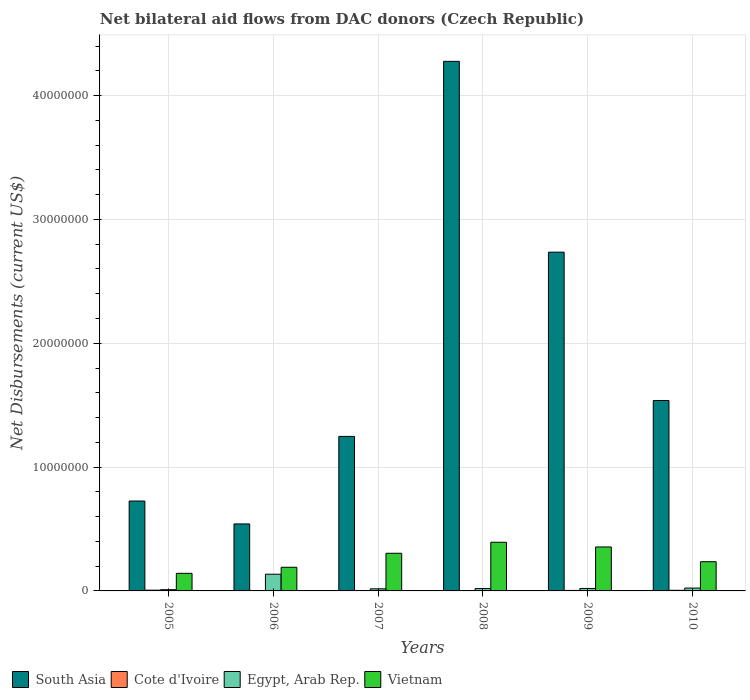How many different coloured bars are there?
Your response must be concise. 4. How many groups of bars are there?
Ensure brevity in your answer.  6. Are the number of bars per tick equal to the number of legend labels?
Keep it short and to the point. Yes. Are the number of bars on each tick of the X-axis equal?
Your response must be concise. Yes. How many bars are there on the 5th tick from the left?
Give a very brief answer. 4. How many bars are there on the 3rd tick from the right?
Your response must be concise. 4. What is the label of the 3rd group of bars from the left?
Keep it short and to the point. 2007. In how many cases, is the number of bars for a given year not equal to the number of legend labels?
Make the answer very short. 0. What is the net bilateral aid flows in Vietnam in 2008?
Make the answer very short. 3.93e+06. Across all years, what is the maximum net bilateral aid flows in Egypt, Arab Rep.?
Your answer should be very brief. 1.35e+06. Across all years, what is the minimum net bilateral aid flows in Cote d'Ivoire?
Keep it short and to the point. 10000. In which year was the net bilateral aid flows in Egypt, Arab Rep. maximum?
Keep it short and to the point. 2006. In which year was the net bilateral aid flows in Vietnam minimum?
Your response must be concise. 2005. What is the total net bilateral aid flows in Vietnam in the graph?
Provide a short and direct response. 1.62e+07. What is the difference between the net bilateral aid flows in Cote d'Ivoire in 2005 and that in 2007?
Provide a succinct answer. 5.00e+04. What is the difference between the net bilateral aid flows in Egypt, Arab Rep. in 2008 and the net bilateral aid flows in Vietnam in 2010?
Offer a very short reply. -2.17e+06. What is the average net bilateral aid flows in South Asia per year?
Ensure brevity in your answer.  1.84e+07. In the year 2010, what is the difference between the net bilateral aid flows in Vietnam and net bilateral aid flows in Cote d'Ivoire?
Make the answer very short. 2.31e+06. In how many years, is the net bilateral aid flows in South Asia greater than 24000000 US$?
Provide a short and direct response. 2. What is the ratio of the net bilateral aid flows in Egypt, Arab Rep. in 2008 to that in 2010?
Your response must be concise. 0.83. Is the difference between the net bilateral aid flows in Vietnam in 2007 and 2010 greater than the difference between the net bilateral aid flows in Cote d'Ivoire in 2007 and 2010?
Provide a succinct answer. Yes. What is the difference between the highest and the second highest net bilateral aid flows in South Asia?
Offer a terse response. 1.54e+07. What is the difference between the highest and the lowest net bilateral aid flows in Cote d'Ivoire?
Give a very brief answer. 5.00e+04. In how many years, is the net bilateral aid flows in Vietnam greater than the average net bilateral aid flows in Vietnam taken over all years?
Provide a succinct answer. 3. Is the sum of the net bilateral aid flows in Vietnam in 2007 and 2008 greater than the maximum net bilateral aid flows in South Asia across all years?
Offer a very short reply. No. Is it the case that in every year, the sum of the net bilateral aid flows in Cote d'Ivoire and net bilateral aid flows in South Asia is greater than the sum of net bilateral aid flows in Egypt, Arab Rep. and net bilateral aid flows in Vietnam?
Your response must be concise. Yes. What does the 1st bar from the right in 2005 represents?
Give a very brief answer. Vietnam. How many bars are there?
Give a very brief answer. 24. Are all the bars in the graph horizontal?
Provide a succinct answer. No. How many years are there in the graph?
Offer a very short reply. 6. Does the graph contain any zero values?
Your answer should be compact. No. Does the graph contain grids?
Your answer should be compact. Yes. Where does the legend appear in the graph?
Your response must be concise. Bottom left. How many legend labels are there?
Give a very brief answer. 4. How are the legend labels stacked?
Your response must be concise. Horizontal. What is the title of the graph?
Offer a very short reply. Net bilateral aid flows from DAC donors (Czech Republic). Does "Kosovo" appear as one of the legend labels in the graph?
Make the answer very short. No. What is the label or title of the X-axis?
Offer a terse response. Years. What is the label or title of the Y-axis?
Provide a succinct answer. Net Disbursements (current US$). What is the Net Disbursements (current US$) in South Asia in 2005?
Provide a short and direct response. 7.26e+06. What is the Net Disbursements (current US$) in Vietnam in 2005?
Keep it short and to the point. 1.42e+06. What is the Net Disbursements (current US$) in South Asia in 2006?
Give a very brief answer. 5.41e+06. What is the Net Disbursements (current US$) in Cote d'Ivoire in 2006?
Your response must be concise. 3.00e+04. What is the Net Disbursements (current US$) in Egypt, Arab Rep. in 2006?
Your response must be concise. 1.35e+06. What is the Net Disbursements (current US$) in Vietnam in 2006?
Give a very brief answer. 1.91e+06. What is the Net Disbursements (current US$) in South Asia in 2007?
Provide a succinct answer. 1.25e+07. What is the Net Disbursements (current US$) in Vietnam in 2007?
Your answer should be very brief. 3.04e+06. What is the Net Disbursements (current US$) of South Asia in 2008?
Ensure brevity in your answer.  4.28e+07. What is the Net Disbursements (current US$) of Vietnam in 2008?
Your response must be concise. 3.93e+06. What is the Net Disbursements (current US$) of South Asia in 2009?
Give a very brief answer. 2.74e+07. What is the Net Disbursements (current US$) in Cote d'Ivoire in 2009?
Give a very brief answer. 4.00e+04. What is the Net Disbursements (current US$) in Egypt, Arab Rep. in 2009?
Offer a very short reply. 2.00e+05. What is the Net Disbursements (current US$) of Vietnam in 2009?
Your answer should be compact. 3.55e+06. What is the Net Disbursements (current US$) in South Asia in 2010?
Give a very brief answer. 1.54e+07. What is the Net Disbursements (current US$) in Vietnam in 2010?
Keep it short and to the point. 2.36e+06. Across all years, what is the maximum Net Disbursements (current US$) of South Asia?
Give a very brief answer. 4.28e+07. Across all years, what is the maximum Net Disbursements (current US$) of Cote d'Ivoire?
Provide a succinct answer. 6.00e+04. Across all years, what is the maximum Net Disbursements (current US$) of Egypt, Arab Rep.?
Offer a very short reply. 1.35e+06. Across all years, what is the maximum Net Disbursements (current US$) of Vietnam?
Your answer should be compact. 3.93e+06. Across all years, what is the minimum Net Disbursements (current US$) of South Asia?
Provide a short and direct response. 5.41e+06. Across all years, what is the minimum Net Disbursements (current US$) in Egypt, Arab Rep.?
Make the answer very short. 1.00e+05. Across all years, what is the minimum Net Disbursements (current US$) in Vietnam?
Offer a very short reply. 1.42e+06. What is the total Net Disbursements (current US$) in South Asia in the graph?
Your response must be concise. 1.11e+08. What is the total Net Disbursements (current US$) in Egypt, Arab Rep. in the graph?
Provide a succinct answer. 2.24e+06. What is the total Net Disbursements (current US$) of Vietnam in the graph?
Make the answer very short. 1.62e+07. What is the difference between the Net Disbursements (current US$) in South Asia in 2005 and that in 2006?
Your answer should be compact. 1.85e+06. What is the difference between the Net Disbursements (current US$) of Cote d'Ivoire in 2005 and that in 2006?
Ensure brevity in your answer.  3.00e+04. What is the difference between the Net Disbursements (current US$) in Egypt, Arab Rep. in 2005 and that in 2006?
Provide a succinct answer. -1.25e+06. What is the difference between the Net Disbursements (current US$) of Vietnam in 2005 and that in 2006?
Give a very brief answer. -4.90e+05. What is the difference between the Net Disbursements (current US$) of South Asia in 2005 and that in 2007?
Your response must be concise. -5.22e+06. What is the difference between the Net Disbursements (current US$) in Cote d'Ivoire in 2005 and that in 2007?
Provide a succinct answer. 5.00e+04. What is the difference between the Net Disbursements (current US$) in Vietnam in 2005 and that in 2007?
Your response must be concise. -1.62e+06. What is the difference between the Net Disbursements (current US$) of South Asia in 2005 and that in 2008?
Your answer should be compact. -3.55e+07. What is the difference between the Net Disbursements (current US$) of Cote d'Ivoire in 2005 and that in 2008?
Offer a very short reply. 4.00e+04. What is the difference between the Net Disbursements (current US$) of Vietnam in 2005 and that in 2008?
Make the answer very short. -2.51e+06. What is the difference between the Net Disbursements (current US$) of South Asia in 2005 and that in 2009?
Your answer should be compact. -2.01e+07. What is the difference between the Net Disbursements (current US$) of Egypt, Arab Rep. in 2005 and that in 2009?
Keep it short and to the point. -1.00e+05. What is the difference between the Net Disbursements (current US$) of Vietnam in 2005 and that in 2009?
Provide a succinct answer. -2.13e+06. What is the difference between the Net Disbursements (current US$) in South Asia in 2005 and that in 2010?
Keep it short and to the point. -8.12e+06. What is the difference between the Net Disbursements (current US$) of Cote d'Ivoire in 2005 and that in 2010?
Provide a short and direct response. 10000. What is the difference between the Net Disbursements (current US$) of Vietnam in 2005 and that in 2010?
Your answer should be very brief. -9.40e+05. What is the difference between the Net Disbursements (current US$) of South Asia in 2006 and that in 2007?
Offer a very short reply. -7.07e+06. What is the difference between the Net Disbursements (current US$) of Cote d'Ivoire in 2006 and that in 2007?
Offer a terse response. 2.00e+04. What is the difference between the Net Disbursements (current US$) of Egypt, Arab Rep. in 2006 and that in 2007?
Ensure brevity in your answer.  1.18e+06. What is the difference between the Net Disbursements (current US$) of Vietnam in 2006 and that in 2007?
Provide a succinct answer. -1.13e+06. What is the difference between the Net Disbursements (current US$) in South Asia in 2006 and that in 2008?
Your response must be concise. -3.74e+07. What is the difference between the Net Disbursements (current US$) in Cote d'Ivoire in 2006 and that in 2008?
Keep it short and to the point. 10000. What is the difference between the Net Disbursements (current US$) in Egypt, Arab Rep. in 2006 and that in 2008?
Provide a succinct answer. 1.16e+06. What is the difference between the Net Disbursements (current US$) in Vietnam in 2006 and that in 2008?
Your answer should be very brief. -2.02e+06. What is the difference between the Net Disbursements (current US$) in South Asia in 2006 and that in 2009?
Your answer should be compact. -2.20e+07. What is the difference between the Net Disbursements (current US$) in Cote d'Ivoire in 2006 and that in 2009?
Your answer should be very brief. -10000. What is the difference between the Net Disbursements (current US$) in Egypt, Arab Rep. in 2006 and that in 2009?
Ensure brevity in your answer.  1.15e+06. What is the difference between the Net Disbursements (current US$) in Vietnam in 2006 and that in 2009?
Your answer should be very brief. -1.64e+06. What is the difference between the Net Disbursements (current US$) of South Asia in 2006 and that in 2010?
Your answer should be compact. -9.97e+06. What is the difference between the Net Disbursements (current US$) of Cote d'Ivoire in 2006 and that in 2010?
Keep it short and to the point. -2.00e+04. What is the difference between the Net Disbursements (current US$) in Egypt, Arab Rep. in 2006 and that in 2010?
Your answer should be very brief. 1.12e+06. What is the difference between the Net Disbursements (current US$) of Vietnam in 2006 and that in 2010?
Provide a short and direct response. -4.50e+05. What is the difference between the Net Disbursements (current US$) of South Asia in 2007 and that in 2008?
Your response must be concise. -3.03e+07. What is the difference between the Net Disbursements (current US$) in Vietnam in 2007 and that in 2008?
Keep it short and to the point. -8.90e+05. What is the difference between the Net Disbursements (current US$) in South Asia in 2007 and that in 2009?
Ensure brevity in your answer.  -1.49e+07. What is the difference between the Net Disbursements (current US$) of Vietnam in 2007 and that in 2009?
Make the answer very short. -5.10e+05. What is the difference between the Net Disbursements (current US$) of South Asia in 2007 and that in 2010?
Offer a very short reply. -2.90e+06. What is the difference between the Net Disbursements (current US$) in Vietnam in 2007 and that in 2010?
Your response must be concise. 6.80e+05. What is the difference between the Net Disbursements (current US$) of South Asia in 2008 and that in 2009?
Make the answer very short. 1.54e+07. What is the difference between the Net Disbursements (current US$) in Egypt, Arab Rep. in 2008 and that in 2009?
Provide a short and direct response. -10000. What is the difference between the Net Disbursements (current US$) in Vietnam in 2008 and that in 2009?
Your response must be concise. 3.80e+05. What is the difference between the Net Disbursements (current US$) in South Asia in 2008 and that in 2010?
Provide a succinct answer. 2.74e+07. What is the difference between the Net Disbursements (current US$) of Egypt, Arab Rep. in 2008 and that in 2010?
Give a very brief answer. -4.00e+04. What is the difference between the Net Disbursements (current US$) in Vietnam in 2008 and that in 2010?
Your answer should be compact. 1.57e+06. What is the difference between the Net Disbursements (current US$) in South Asia in 2009 and that in 2010?
Your answer should be compact. 1.20e+07. What is the difference between the Net Disbursements (current US$) of Vietnam in 2009 and that in 2010?
Provide a short and direct response. 1.19e+06. What is the difference between the Net Disbursements (current US$) in South Asia in 2005 and the Net Disbursements (current US$) in Cote d'Ivoire in 2006?
Your response must be concise. 7.23e+06. What is the difference between the Net Disbursements (current US$) in South Asia in 2005 and the Net Disbursements (current US$) in Egypt, Arab Rep. in 2006?
Give a very brief answer. 5.91e+06. What is the difference between the Net Disbursements (current US$) of South Asia in 2005 and the Net Disbursements (current US$) of Vietnam in 2006?
Provide a short and direct response. 5.35e+06. What is the difference between the Net Disbursements (current US$) in Cote d'Ivoire in 2005 and the Net Disbursements (current US$) in Egypt, Arab Rep. in 2006?
Give a very brief answer. -1.29e+06. What is the difference between the Net Disbursements (current US$) of Cote d'Ivoire in 2005 and the Net Disbursements (current US$) of Vietnam in 2006?
Keep it short and to the point. -1.85e+06. What is the difference between the Net Disbursements (current US$) of Egypt, Arab Rep. in 2005 and the Net Disbursements (current US$) of Vietnam in 2006?
Offer a terse response. -1.81e+06. What is the difference between the Net Disbursements (current US$) of South Asia in 2005 and the Net Disbursements (current US$) of Cote d'Ivoire in 2007?
Provide a short and direct response. 7.25e+06. What is the difference between the Net Disbursements (current US$) in South Asia in 2005 and the Net Disbursements (current US$) in Egypt, Arab Rep. in 2007?
Keep it short and to the point. 7.09e+06. What is the difference between the Net Disbursements (current US$) of South Asia in 2005 and the Net Disbursements (current US$) of Vietnam in 2007?
Keep it short and to the point. 4.22e+06. What is the difference between the Net Disbursements (current US$) of Cote d'Ivoire in 2005 and the Net Disbursements (current US$) of Vietnam in 2007?
Ensure brevity in your answer.  -2.98e+06. What is the difference between the Net Disbursements (current US$) in Egypt, Arab Rep. in 2005 and the Net Disbursements (current US$) in Vietnam in 2007?
Provide a succinct answer. -2.94e+06. What is the difference between the Net Disbursements (current US$) of South Asia in 2005 and the Net Disbursements (current US$) of Cote d'Ivoire in 2008?
Offer a very short reply. 7.24e+06. What is the difference between the Net Disbursements (current US$) of South Asia in 2005 and the Net Disbursements (current US$) of Egypt, Arab Rep. in 2008?
Your answer should be very brief. 7.07e+06. What is the difference between the Net Disbursements (current US$) of South Asia in 2005 and the Net Disbursements (current US$) of Vietnam in 2008?
Your answer should be very brief. 3.33e+06. What is the difference between the Net Disbursements (current US$) in Cote d'Ivoire in 2005 and the Net Disbursements (current US$) in Vietnam in 2008?
Offer a very short reply. -3.87e+06. What is the difference between the Net Disbursements (current US$) of Egypt, Arab Rep. in 2005 and the Net Disbursements (current US$) of Vietnam in 2008?
Give a very brief answer. -3.83e+06. What is the difference between the Net Disbursements (current US$) of South Asia in 2005 and the Net Disbursements (current US$) of Cote d'Ivoire in 2009?
Your response must be concise. 7.22e+06. What is the difference between the Net Disbursements (current US$) in South Asia in 2005 and the Net Disbursements (current US$) in Egypt, Arab Rep. in 2009?
Provide a succinct answer. 7.06e+06. What is the difference between the Net Disbursements (current US$) in South Asia in 2005 and the Net Disbursements (current US$) in Vietnam in 2009?
Provide a succinct answer. 3.71e+06. What is the difference between the Net Disbursements (current US$) of Cote d'Ivoire in 2005 and the Net Disbursements (current US$) of Vietnam in 2009?
Make the answer very short. -3.49e+06. What is the difference between the Net Disbursements (current US$) in Egypt, Arab Rep. in 2005 and the Net Disbursements (current US$) in Vietnam in 2009?
Offer a terse response. -3.45e+06. What is the difference between the Net Disbursements (current US$) of South Asia in 2005 and the Net Disbursements (current US$) of Cote d'Ivoire in 2010?
Offer a terse response. 7.21e+06. What is the difference between the Net Disbursements (current US$) of South Asia in 2005 and the Net Disbursements (current US$) of Egypt, Arab Rep. in 2010?
Offer a very short reply. 7.03e+06. What is the difference between the Net Disbursements (current US$) in South Asia in 2005 and the Net Disbursements (current US$) in Vietnam in 2010?
Ensure brevity in your answer.  4.90e+06. What is the difference between the Net Disbursements (current US$) of Cote d'Ivoire in 2005 and the Net Disbursements (current US$) of Vietnam in 2010?
Your answer should be compact. -2.30e+06. What is the difference between the Net Disbursements (current US$) in Egypt, Arab Rep. in 2005 and the Net Disbursements (current US$) in Vietnam in 2010?
Offer a terse response. -2.26e+06. What is the difference between the Net Disbursements (current US$) of South Asia in 2006 and the Net Disbursements (current US$) of Cote d'Ivoire in 2007?
Make the answer very short. 5.40e+06. What is the difference between the Net Disbursements (current US$) in South Asia in 2006 and the Net Disbursements (current US$) in Egypt, Arab Rep. in 2007?
Your response must be concise. 5.24e+06. What is the difference between the Net Disbursements (current US$) in South Asia in 2006 and the Net Disbursements (current US$) in Vietnam in 2007?
Offer a terse response. 2.37e+06. What is the difference between the Net Disbursements (current US$) of Cote d'Ivoire in 2006 and the Net Disbursements (current US$) of Egypt, Arab Rep. in 2007?
Make the answer very short. -1.40e+05. What is the difference between the Net Disbursements (current US$) of Cote d'Ivoire in 2006 and the Net Disbursements (current US$) of Vietnam in 2007?
Provide a short and direct response. -3.01e+06. What is the difference between the Net Disbursements (current US$) in Egypt, Arab Rep. in 2006 and the Net Disbursements (current US$) in Vietnam in 2007?
Your response must be concise. -1.69e+06. What is the difference between the Net Disbursements (current US$) in South Asia in 2006 and the Net Disbursements (current US$) in Cote d'Ivoire in 2008?
Offer a very short reply. 5.39e+06. What is the difference between the Net Disbursements (current US$) in South Asia in 2006 and the Net Disbursements (current US$) in Egypt, Arab Rep. in 2008?
Give a very brief answer. 5.22e+06. What is the difference between the Net Disbursements (current US$) in South Asia in 2006 and the Net Disbursements (current US$) in Vietnam in 2008?
Your answer should be compact. 1.48e+06. What is the difference between the Net Disbursements (current US$) in Cote d'Ivoire in 2006 and the Net Disbursements (current US$) in Egypt, Arab Rep. in 2008?
Your response must be concise. -1.60e+05. What is the difference between the Net Disbursements (current US$) of Cote d'Ivoire in 2006 and the Net Disbursements (current US$) of Vietnam in 2008?
Give a very brief answer. -3.90e+06. What is the difference between the Net Disbursements (current US$) of Egypt, Arab Rep. in 2006 and the Net Disbursements (current US$) of Vietnam in 2008?
Make the answer very short. -2.58e+06. What is the difference between the Net Disbursements (current US$) of South Asia in 2006 and the Net Disbursements (current US$) of Cote d'Ivoire in 2009?
Provide a succinct answer. 5.37e+06. What is the difference between the Net Disbursements (current US$) of South Asia in 2006 and the Net Disbursements (current US$) of Egypt, Arab Rep. in 2009?
Your answer should be compact. 5.21e+06. What is the difference between the Net Disbursements (current US$) in South Asia in 2006 and the Net Disbursements (current US$) in Vietnam in 2009?
Your response must be concise. 1.86e+06. What is the difference between the Net Disbursements (current US$) in Cote d'Ivoire in 2006 and the Net Disbursements (current US$) in Egypt, Arab Rep. in 2009?
Give a very brief answer. -1.70e+05. What is the difference between the Net Disbursements (current US$) in Cote d'Ivoire in 2006 and the Net Disbursements (current US$) in Vietnam in 2009?
Your answer should be very brief. -3.52e+06. What is the difference between the Net Disbursements (current US$) of Egypt, Arab Rep. in 2006 and the Net Disbursements (current US$) of Vietnam in 2009?
Provide a succinct answer. -2.20e+06. What is the difference between the Net Disbursements (current US$) of South Asia in 2006 and the Net Disbursements (current US$) of Cote d'Ivoire in 2010?
Your answer should be very brief. 5.36e+06. What is the difference between the Net Disbursements (current US$) in South Asia in 2006 and the Net Disbursements (current US$) in Egypt, Arab Rep. in 2010?
Ensure brevity in your answer.  5.18e+06. What is the difference between the Net Disbursements (current US$) of South Asia in 2006 and the Net Disbursements (current US$) of Vietnam in 2010?
Give a very brief answer. 3.05e+06. What is the difference between the Net Disbursements (current US$) of Cote d'Ivoire in 2006 and the Net Disbursements (current US$) of Vietnam in 2010?
Provide a short and direct response. -2.33e+06. What is the difference between the Net Disbursements (current US$) of Egypt, Arab Rep. in 2006 and the Net Disbursements (current US$) of Vietnam in 2010?
Give a very brief answer. -1.01e+06. What is the difference between the Net Disbursements (current US$) in South Asia in 2007 and the Net Disbursements (current US$) in Cote d'Ivoire in 2008?
Make the answer very short. 1.25e+07. What is the difference between the Net Disbursements (current US$) of South Asia in 2007 and the Net Disbursements (current US$) of Egypt, Arab Rep. in 2008?
Give a very brief answer. 1.23e+07. What is the difference between the Net Disbursements (current US$) in South Asia in 2007 and the Net Disbursements (current US$) in Vietnam in 2008?
Your answer should be compact. 8.55e+06. What is the difference between the Net Disbursements (current US$) in Cote d'Ivoire in 2007 and the Net Disbursements (current US$) in Vietnam in 2008?
Your answer should be very brief. -3.92e+06. What is the difference between the Net Disbursements (current US$) of Egypt, Arab Rep. in 2007 and the Net Disbursements (current US$) of Vietnam in 2008?
Keep it short and to the point. -3.76e+06. What is the difference between the Net Disbursements (current US$) of South Asia in 2007 and the Net Disbursements (current US$) of Cote d'Ivoire in 2009?
Offer a very short reply. 1.24e+07. What is the difference between the Net Disbursements (current US$) of South Asia in 2007 and the Net Disbursements (current US$) of Egypt, Arab Rep. in 2009?
Your response must be concise. 1.23e+07. What is the difference between the Net Disbursements (current US$) in South Asia in 2007 and the Net Disbursements (current US$) in Vietnam in 2009?
Give a very brief answer. 8.93e+06. What is the difference between the Net Disbursements (current US$) of Cote d'Ivoire in 2007 and the Net Disbursements (current US$) of Egypt, Arab Rep. in 2009?
Offer a terse response. -1.90e+05. What is the difference between the Net Disbursements (current US$) in Cote d'Ivoire in 2007 and the Net Disbursements (current US$) in Vietnam in 2009?
Offer a terse response. -3.54e+06. What is the difference between the Net Disbursements (current US$) of Egypt, Arab Rep. in 2007 and the Net Disbursements (current US$) of Vietnam in 2009?
Offer a terse response. -3.38e+06. What is the difference between the Net Disbursements (current US$) in South Asia in 2007 and the Net Disbursements (current US$) in Cote d'Ivoire in 2010?
Your answer should be very brief. 1.24e+07. What is the difference between the Net Disbursements (current US$) of South Asia in 2007 and the Net Disbursements (current US$) of Egypt, Arab Rep. in 2010?
Ensure brevity in your answer.  1.22e+07. What is the difference between the Net Disbursements (current US$) in South Asia in 2007 and the Net Disbursements (current US$) in Vietnam in 2010?
Give a very brief answer. 1.01e+07. What is the difference between the Net Disbursements (current US$) of Cote d'Ivoire in 2007 and the Net Disbursements (current US$) of Egypt, Arab Rep. in 2010?
Your response must be concise. -2.20e+05. What is the difference between the Net Disbursements (current US$) in Cote d'Ivoire in 2007 and the Net Disbursements (current US$) in Vietnam in 2010?
Your answer should be very brief. -2.35e+06. What is the difference between the Net Disbursements (current US$) of Egypt, Arab Rep. in 2007 and the Net Disbursements (current US$) of Vietnam in 2010?
Make the answer very short. -2.19e+06. What is the difference between the Net Disbursements (current US$) in South Asia in 2008 and the Net Disbursements (current US$) in Cote d'Ivoire in 2009?
Ensure brevity in your answer.  4.27e+07. What is the difference between the Net Disbursements (current US$) in South Asia in 2008 and the Net Disbursements (current US$) in Egypt, Arab Rep. in 2009?
Keep it short and to the point. 4.26e+07. What is the difference between the Net Disbursements (current US$) of South Asia in 2008 and the Net Disbursements (current US$) of Vietnam in 2009?
Keep it short and to the point. 3.92e+07. What is the difference between the Net Disbursements (current US$) of Cote d'Ivoire in 2008 and the Net Disbursements (current US$) of Vietnam in 2009?
Your answer should be compact. -3.53e+06. What is the difference between the Net Disbursements (current US$) in Egypt, Arab Rep. in 2008 and the Net Disbursements (current US$) in Vietnam in 2009?
Make the answer very short. -3.36e+06. What is the difference between the Net Disbursements (current US$) in South Asia in 2008 and the Net Disbursements (current US$) in Cote d'Ivoire in 2010?
Your response must be concise. 4.27e+07. What is the difference between the Net Disbursements (current US$) of South Asia in 2008 and the Net Disbursements (current US$) of Egypt, Arab Rep. in 2010?
Give a very brief answer. 4.25e+07. What is the difference between the Net Disbursements (current US$) of South Asia in 2008 and the Net Disbursements (current US$) of Vietnam in 2010?
Your answer should be compact. 4.04e+07. What is the difference between the Net Disbursements (current US$) in Cote d'Ivoire in 2008 and the Net Disbursements (current US$) in Vietnam in 2010?
Your answer should be very brief. -2.34e+06. What is the difference between the Net Disbursements (current US$) of Egypt, Arab Rep. in 2008 and the Net Disbursements (current US$) of Vietnam in 2010?
Your response must be concise. -2.17e+06. What is the difference between the Net Disbursements (current US$) of South Asia in 2009 and the Net Disbursements (current US$) of Cote d'Ivoire in 2010?
Your response must be concise. 2.73e+07. What is the difference between the Net Disbursements (current US$) in South Asia in 2009 and the Net Disbursements (current US$) in Egypt, Arab Rep. in 2010?
Provide a short and direct response. 2.71e+07. What is the difference between the Net Disbursements (current US$) in South Asia in 2009 and the Net Disbursements (current US$) in Vietnam in 2010?
Keep it short and to the point. 2.50e+07. What is the difference between the Net Disbursements (current US$) in Cote d'Ivoire in 2009 and the Net Disbursements (current US$) in Egypt, Arab Rep. in 2010?
Your response must be concise. -1.90e+05. What is the difference between the Net Disbursements (current US$) in Cote d'Ivoire in 2009 and the Net Disbursements (current US$) in Vietnam in 2010?
Offer a terse response. -2.32e+06. What is the difference between the Net Disbursements (current US$) of Egypt, Arab Rep. in 2009 and the Net Disbursements (current US$) of Vietnam in 2010?
Make the answer very short. -2.16e+06. What is the average Net Disbursements (current US$) of South Asia per year?
Your response must be concise. 1.84e+07. What is the average Net Disbursements (current US$) in Cote d'Ivoire per year?
Ensure brevity in your answer.  3.50e+04. What is the average Net Disbursements (current US$) of Egypt, Arab Rep. per year?
Your response must be concise. 3.73e+05. What is the average Net Disbursements (current US$) in Vietnam per year?
Ensure brevity in your answer.  2.70e+06. In the year 2005, what is the difference between the Net Disbursements (current US$) in South Asia and Net Disbursements (current US$) in Cote d'Ivoire?
Offer a very short reply. 7.20e+06. In the year 2005, what is the difference between the Net Disbursements (current US$) in South Asia and Net Disbursements (current US$) in Egypt, Arab Rep.?
Your answer should be compact. 7.16e+06. In the year 2005, what is the difference between the Net Disbursements (current US$) of South Asia and Net Disbursements (current US$) of Vietnam?
Ensure brevity in your answer.  5.84e+06. In the year 2005, what is the difference between the Net Disbursements (current US$) in Cote d'Ivoire and Net Disbursements (current US$) in Egypt, Arab Rep.?
Offer a very short reply. -4.00e+04. In the year 2005, what is the difference between the Net Disbursements (current US$) in Cote d'Ivoire and Net Disbursements (current US$) in Vietnam?
Ensure brevity in your answer.  -1.36e+06. In the year 2005, what is the difference between the Net Disbursements (current US$) of Egypt, Arab Rep. and Net Disbursements (current US$) of Vietnam?
Ensure brevity in your answer.  -1.32e+06. In the year 2006, what is the difference between the Net Disbursements (current US$) in South Asia and Net Disbursements (current US$) in Cote d'Ivoire?
Keep it short and to the point. 5.38e+06. In the year 2006, what is the difference between the Net Disbursements (current US$) in South Asia and Net Disbursements (current US$) in Egypt, Arab Rep.?
Your answer should be compact. 4.06e+06. In the year 2006, what is the difference between the Net Disbursements (current US$) of South Asia and Net Disbursements (current US$) of Vietnam?
Give a very brief answer. 3.50e+06. In the year 2006, what is the difference between the Net Disbursements (current US$) of Cote d'Ivoire and Net Disbursements (current US$) of Egypt, Arab Rep.?
Make the answer very short. -1.32e+06. In the year 2006, what is the difference between the Net Disbursements (current US$) of Cote d'Ivoire and Net Disbursements (current US$) of Vietnam?
Your response must be concise. -1.88e+06. In the year 2006, what is the difference between the Net Disbursements (current US$) in Egypt, Arab Rep. and Net Disbursements (current US$) in Vietnam?
Keep it short and to the point. -5.60e+05. In the year 2007, what is the difference between the Net Disbursements (current US$) of South Asia and Net Disbursements (current US$) of Cote d'Ivoire?
Keep it short and to the point. 1.25e+07. In the year 2007, what is the difference between the Net Disbursements (current US$) in South Asia and Net Disbursements (current US$) in Egypt, Arab Rep.?
Provide a succinct answer. 1.23e+07. In the year 2007, what is the difference between the Net Disbursements (current US$) of South Asia and Net Disbursements (current US$) of Vietnam?
Offer a very short reply. 9.44e+06. In the year 2007, what is the difference between the Net Disbursements (current US$) of Cote d'Ivoire and Net Disbursements (current US$) of Vietnam?
Your answer should be very brief. -3.03e+06. In the year 2007, what is the difference between the Net Disbursements (current US$) in Egypt, Arab Rep. and Net Disbursements (current US$) in Vietnam?
Provide a succinct answer. -2.87e+06. In the year 2008, what is the difference between the Net Disbursements (current US$) in South Asia and Net Disbursements (current US$) in Cote d'Ivoire?
Make the answer very short. 4.28e+07. In the year 2008, what is the difference between the Net Disbursements (current US$) in South Asia and Net Disbursements (current US$) in Egypt, Arab Rep.?
Keep it short and to the point. 4.26e+07. In the year 2008, what is the difference between the Net Disbursements (current US$) in South Asia and Net Disbursements (current US$) in Vietnam?
Ensure brevity in your answer.  3.88e+07. In the year 2008, what is the difference between the Net Disbursements (current US$) of Cote d'Ivoire and Net Disbursements (current US$) of Vietnam?
Your response must be concise. -3.91e+06. In the year 2008, what is the difference between the Net Disbursements (current US$) of Egypt, Arab Rep. and Net Disbursements (current US$) of Vietnam?
Your response must be concise. -3.74e+06. In the year 2009, what is the difference between the Net Disbursements (current US$) in South Asia and Net Disbursements (current US$) in Cote d'Ivoire?
Provide a short and direct response. 2.73e+07. In the year 2009, what is the difference between the Net Disbursements (current US$) in South Asia and Net Disbursements (current US$) in Egypt, Arab Rep.?
Ensure brevity in your answer.  2.72e+07. In the year 2009, what is the difference between the Net Disbursements (current US$) in South Asia and Net Disbursements (current US$) in Vietnam?
Ensure brevity in your answer.  2.38e+07. In the year 2009, what is the difference between the Net Disbursements (current US$) of Cote d'Ivoire and Net Disbursements (current US$) of Egypt, Arab Rep.?
Offer a terse response. -1.60e+05. In the year 2009, what is the difference between the Net Disbursements (current US$) of Cote d'Ivoire and Net Disbursements (current US$) of Vietnam?
Offer a very short reply. -3.51e+06. In the year 2009, what is the difference between the Net Disbursements (current US$) in Egypt, Arab Rep. and Net Disbursements (current US$) in Vietnam?
Give a very brief answer. -3.35e+06. In the year 2010, what is the difference between the Net Disbursements (current US$) in South Asia and Net Disbursements (current US$) in Cote d'Ivoire?
Provide a short and direct response. 1.53e+07. In the year 2010, what is the difference between the Net Disbursements (current US$) in South Asia and Net Disbursements (current US$) in Egypt, Arab Rep.?
Your answer should be compact. 1.52e+07. In the year 2010, what is the difference between the Net Disbursements (current US$) of South Asia and Net Disbursements (current US$) of Vietnam?
Offer a very short reply. 1.30e+07. In the year 2010, what is the difference between the Net Disbursements (current US$) in Cote d'Ivoire and Net Disbursements (current US$) in Egypt, Arab Rep.?
Ensure brevity in your answer.  -1.80e+05. In the year 2010, what is the difference between the Net Disbursements (current US$) in Cote d'Ivoire and Net Disbursements (current US$) in Vietnam?
Your answer should be compact. -2.31e+06. In the year 2010, what is the difference between the Net Disbursements (current US$) of Egypt, Arab Rep. and Net Disbursements (current US$) of Vietnam?
Offer a very short reply. -2.13e+06. What is the ratio of the Net Disbursements (current US$) of South Asia in 2005 to that in 2006?
Your answer should be very brief. 1.34. What is the ratio of the Net Disbursements (current US$) in Egypt, Arab Rep. in 2005 to that in 2006?
Offer a terse response. 0.07. What is the ratio of the Net Disbursements (current US$) of Vietnam in 2005 to that in 2006?
Offer a very short reply. 0.74. What is the ratio of the Net Disbursements (current US$) of South Asia in 2005 to that in 2007?
Your answer should be very brief. 0.58. What is the ratio of the Net Disbursements (current US$) in Cote d'Ivoire in 2005 to that in 2007?
Ensure brevity in your answer.  6. What is the ratio of the Net Disbursements (current US$) of Egypt, Arab Rep. in 2005 to that in 2007?
Make the answer very short. 0.59. What is the ratio of the Net Disbursements (current US$) of Vietnam in 2005 to that in 2007?
Provide a succinct answer. 0.47. What is the ratio of the Net Disbursements (current US$) of South Asia in 2005 to that in 2008?
Keep it short and to the point. 0.17. What is the ratio of the Net Disbursements (current US$) of Cote d'Ivoire in 2005 to that in 2008?
Give a very brief answer. 3. What is the ratio of the Net Disbursements (current US$) of Egypt, Arab Rep. in 2005 to that in 2008?
Give a very brief answer. 0.53. What is the ratio of the Net Disbursements (current US$) of Vietnam in 2005 to that in 2008?
Make the answer very short. 0.36. What is the ratio of the Net Disbursements (current US$) in South Asia in 2005 to that in 2009?
Provide a succinct answer. 0.27. What is the ratio of the Net Disbursements (current US$) of Egypt, Arab Rep. in 2005 to that in 2009?
Your answer should be compact. 0.5. What is the ratio of the Net Disbursements (current US$) in Vietnam in 2005 to that in 2009?
Keep it short and to the point. 0.4. What is the ratio of the Net Disbursements (current US$) in South Asia in 2005 to that in 2010?
Offer a terse response. 0.47. What is the ratio of the Net Disbursements (current US$) in Cote d'Ivoire in 2005 to that in 2010?
Provide a short and direct response. 1.2. What is the ratio of the Net Disbursements (current US$) in Egypt, Arab Rep. in 2005 to that in 2010?
Your response must be concise. 0.43. What is the ratio of the Net Disbursements (current US$) of Vietnam in 2005 to that in 2010?
Make the answer very short. 0.6. What is the ratio of the Net Disbursements (current US$) in South Asia in 2006 to that in 2007?
Provide a succinct answer. 0.43. What is the ratio of the Net Disbursements (current US$) in Cote d'Ivoire in 2006 to that in 2007?
Provide a short and direct response. 3. What is the ratio of the Net Disbursements (current US$) in Egypt, Arab Rep. in 2006 to that in 2007?
Ensure brevity in your answer.  7.94. What is the ratio of the Net Disbursements (current US$) in Vietnam in 2006 to that in 2007?
Your answer should be very brief. 0.63. What is the ratio of the Net Disbursements (current US$) of South Asia in 2006 to that in 2008?
Offer a terse response. 0.13. What is the ratio of the Net Disbursements (current US$) of Cote d'Ivoire in 2006 to that in 2008?
Provide a succinct answer. 1.5. What is the ratio of the Net Disbursements (current US$) of Egypt, Arab Rep. in 2006 to that in 2008?
Offer a terse response. 7.11. What is the ratio of the Net Disbursements (current US$) of Vietnam in 2006 to that in 2008?
Provide a succinct answer. 0.49. What is the ratio of the Net Disbursements (current US$) of South Asia in 2006 to that in 2009?
Make the answer very short. 0.2. What is the ratio of the Net Disbursements (current US$) in Cote d'Ivoire in 2006 to that in 2009?
Your answer should be very brief. 0.75. What is the ratio of the Net Disbursements (current US$) in Egypt, Arab Rep. in 2006 to that in 2009?
Provide a succinct answer. 6.75. What is the ratio of the Net Disbursements (current US$) in Vietnam in 2006 to that in 2009?
Your response must be concise. 0.54. What is the ratio of the Net Disbursements (current US$) in South Asia in 2006 to that in 2010?
Your answer should be very brief. 0.35. What is the ratio of the Net Disbursements (current US$) of Egypt, Arab Rep. in 2006 to that in 2010?
Your answer should be very brief. 5.87. What is the ratio of the Net Disbursements (current US$) in Vietnam in 2006 to that in 2010?
Provide a short and direct response. 0.81. What is the ratio of the Net Disbursements (current US$) of South Asia in 2007 to that in 2008?
Offer a very short reply. 0.29. What is the ratio of the Net Disbursements (current US$) of Egypt, Arab Rep. in 2007 to that in 2008?
Ensure brevity in your answer.  0.89. What is the ratio of the Net Disbursements (current US$) in Vietnam in 2007 to that in 2008?
Keep it short and to the point. 0.77. What is the ratio of the Net Disbursements (current US$) of South Asia in 2007 to that in 2009?
Provide a succinct answer. 0.46. What is the ratio of the Net Disbursements (current US$) in Cote d'Ivoire in 2007 to that in 2009?
Provide a short and direct response. 0.25. What is the ratio of the Net Disbursements (current US$) of Vietnam in 2007 to that in 2009?
Provide a succinct answer. 0.86. What is the ratio of the Net Disbursements (current US$) of South Asia in 2007 to that in 2010?
Provide a short and direct response. 0.81. What is the ratio of the Net Disbursements (current US$) in Egypt, Arab Rep. in 2007 to that in 2010?
Your answer should be compact. 0.74. What is the ratio of the Net Disbursements (current US$) of Vietnam in 2007 to that in 2010?
Keep it short and to the point. 1.29. What is the ratio of the Net Disbursements (current US$) in South Asia in 2008 to that in 2009?
Your response must be concise. 1.56. What is the ratio of the Net Disbursements (current US$) of Egypt, Arab Rep. in 2008 to that in 2009?
Provide a short and direct response. 0.95. What is the ratio of the Net Disbursements (current US$) in Vietnam in 2008 to that in 2009?
Ensure brevity in your answer.  1.11. What is the ratio of the Net Disbursements (current US$) in South Asia in 2008 to that in 2010?
Keep it short and to the point. 2.78. What is the ratio of the Net Disbursements (current US$) in Egypt, Arab Rep. in 2008 to that in 2010?
Make the answer very short. 0.83. What is the ratio of the Net Disbursements (current US$) in Vietnam in 2008 to that in 2010?
Give a very brief answer. 1.67. What is the ratio of the Net Disbursements (current US$) in South Asia in 2009 to that in 2010?
Give a very brief answer. 1.78. What is the ratio of the Net Disbursements (current US$) of Egypt, Arab Rep. in 2009 to that in 2010?
Your response must be concise. 0.87. What is the ratio of the Net Disbursements (current US$) in Vietnam in 2009 to that in 2010?
Your answer should be compact. 1.5. What is the difference between the highest and the second highest Net Disbursements (current US$) of South Asia?
Ensure brevity in your answer.  1.54e+07. What is the difference between the highest and the second highest Net Disbursements (current US$) of Cote d'Ivoire?
Keep it short and to the point. 10000. What is the difference between the highest and the second highest Net Disbursements (current US$) of Egypt, Arab Rep.?
Provide a succinct answer. 1.12e+06. What is the difference between the highest and the second highest Net Disbursements (current US$) of Vietnam?
Give a very brief answer. 3.80e+05. What is the difference between the highest and the lowest Net Disbursements (current US$) of South Asia?
Offer a terse response. 3.74e+07. What is the difference between the highest and the lowest Net Disbursements (current US$) of Egypt, Arab Rep.?
Offer a very short reply. 1.25e+06. What is the difference between the highest and the lowest Net Disbursements (current US$) of Vietnam?
Provide a short and direct response. 2.51e+06. 